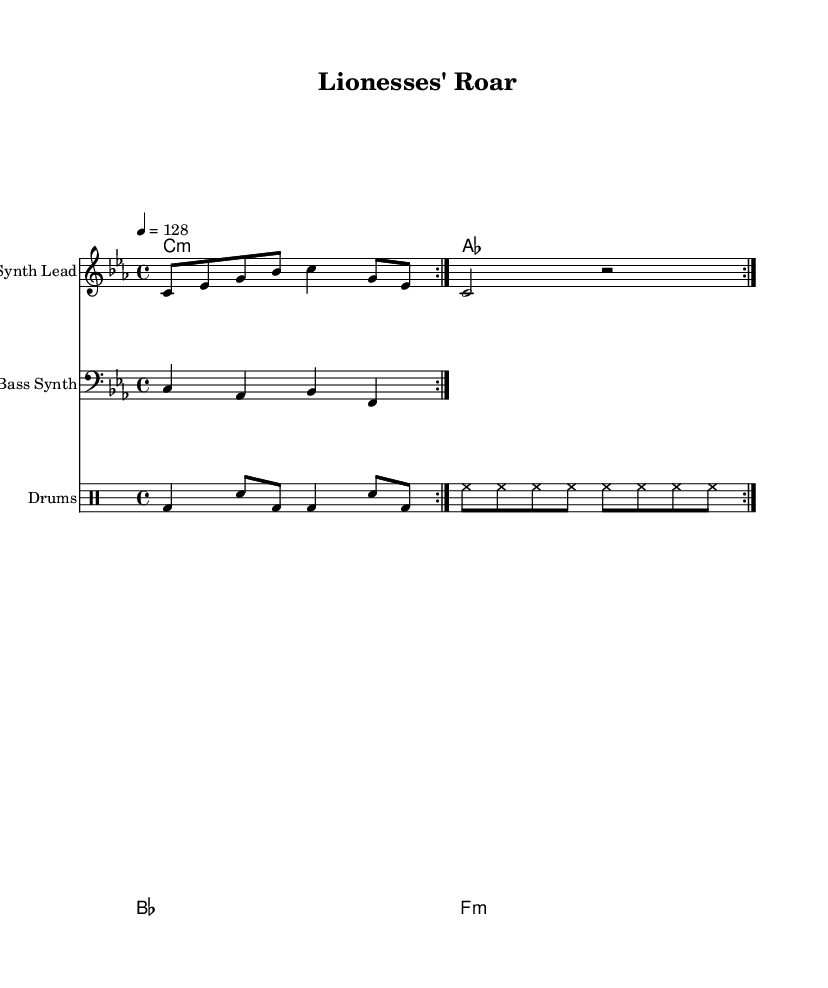What is the key signature of this music? The key signature is C minor, which has three flats (B flat, E flat, A flat). This is indicated by the 'c' at the beginning of the global section of the sheet music, showing that the music is based on the C minor scale.
Answer: C minor What is the time signature of this music? The time signature is 4/4, indicated by the 'time 4/4' line in the global settings. This means there are four beats per measure and a quarter note receives one beat.
Answer: 4/4 What is the tempo marking of this piece? The tempo marking is indicated as '4 = 128' in the global section, meaning that a quarter note is set to 128 beats per minute. This indicates a fast-paced rhythm suitable for energetic tracks.
Answer: 128 How many times is the synth lead repeated? The synth lead pattern is indicated to be repeated 2 times, as specified by the 'repeat volta 2' notation. This signifies that the section should be played twice in succession.
Answer: 2 What instrument is used for the bass part? The bass part is indicated with the label 'Bass Synth' in the staff heading, and it is written in the bass clef as denoted by the clef marking before the notes.
Answer: Bass Synth What type of music is represented in this sheet? This sheet music represents energetic electronic tracks, specifically tailored for pre-match warm-ups and fan gatherings, as suggested by the title "Lionesses' Roar" and the upbeat tempo.
Answer: Energetic electronic tracks What is the first chord listed in the chord names? The first chord listed in the chord names section is C minor, as shown by the 'c1:m' at the beginning, representing the chord and its type.
Answer: C minor 